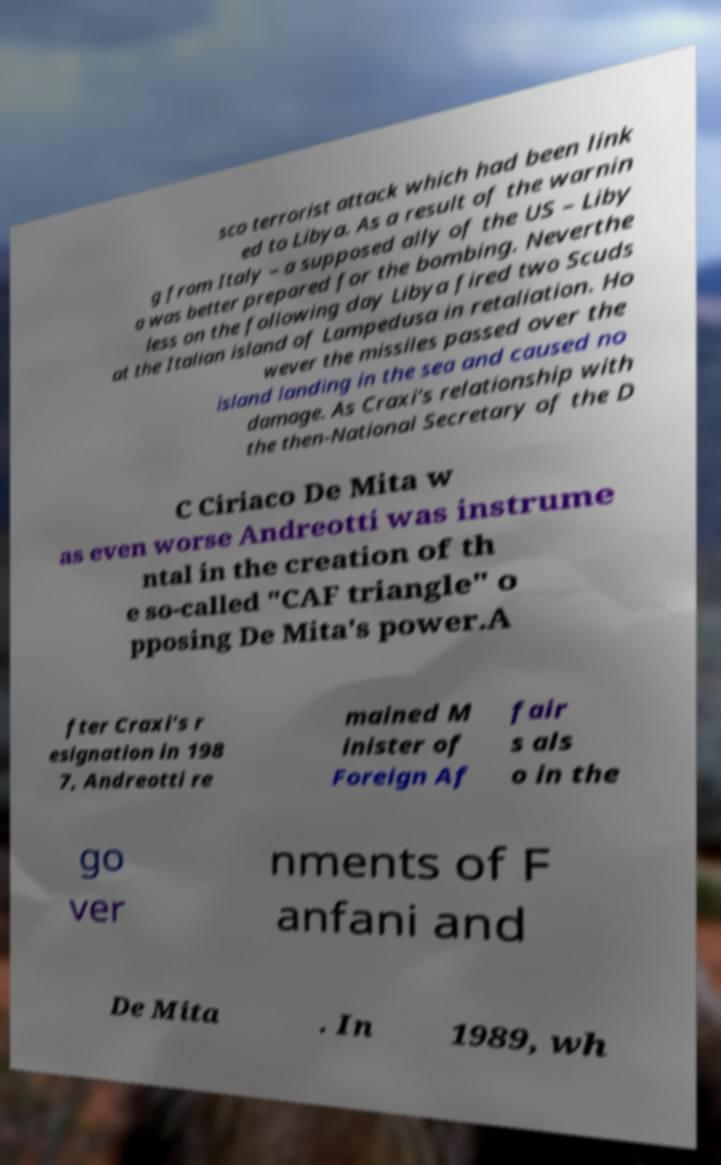I need the written content from this picture converted into text. Can you do that? sco terrorist attack which had been link ed to Libya. As a result of the warnin g from Italy – a supposed ally of the US – Liby a was better prepared for the bombing. Neverthe less on the following day Libya fired two Scuds at the Italian island of Lampedusa in retaliation. Ho wever the missiles passed over the island landing in the sea and caused no damage. As Craxi's relationship with the then-National Secretary of the D C Ciriaco De Mita w as even worse Andreotti was instrume ntal in the creation of th e so-called "CAF triangle" o pposing De Mita's power.A fter Craxi's r esignation in 198 7, Andreotti re mained M inister of Foreign Af fair s als o in the go ver nments of F anfani and De Mita . In 1989, wh 